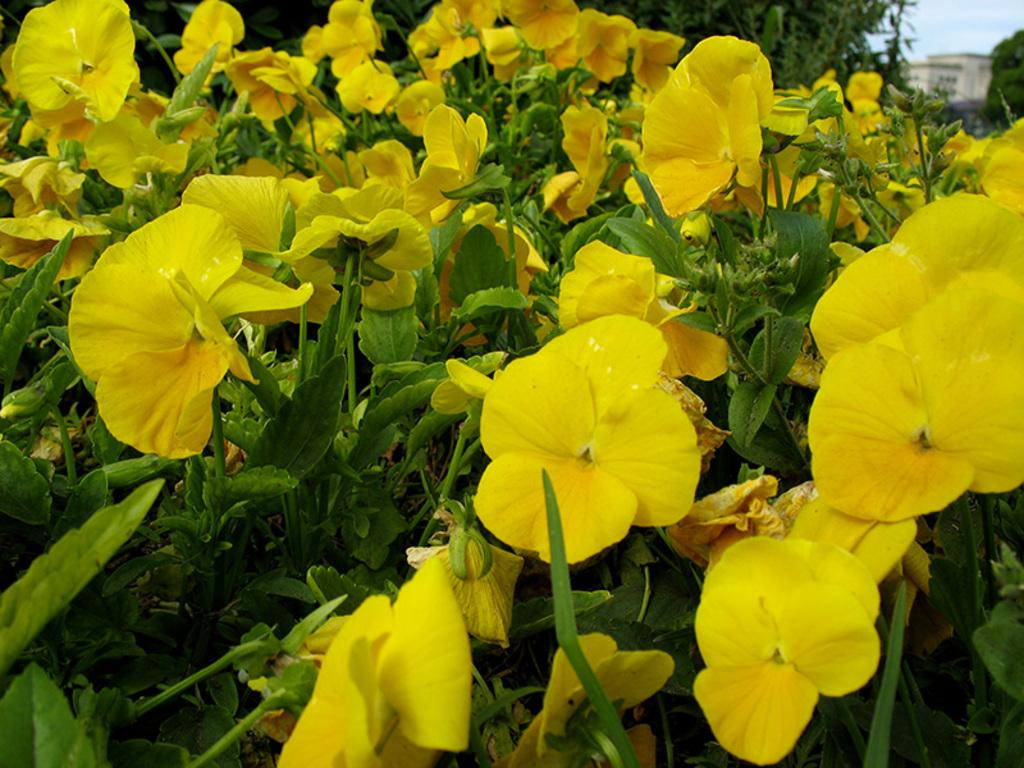What type of living organisms can be seen in the image? There are flowers and plants visible in the image. Can you describe the background of the image? The background of the image is blurry, and the sky is visible. What is the income of the kitty in the image? There is no kitty present in the image, so it is not possible to determine its income. 